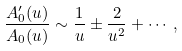<formula> <loc_0><loc_0><loc_500><loc_500>\frac { A ^ { \prime } _ { 0 } ( u ) } { A _ { 0 } ( u ) } \sim \frac { 1 } { u } \pm \frac { 2 } { u ^ { 2 } } + \cdots ,</formula> 